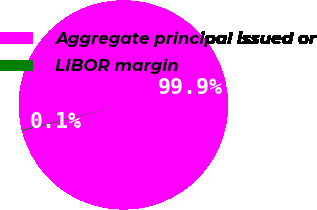Convert chart. <chart><loc_0><loc_0><loc_500><loc_500><pie_chart><fcel>Aggregate principal issued or<fcel>LIBOR margin<nl><fcel>99.89%<fcel>0.11%<nl></chart> 